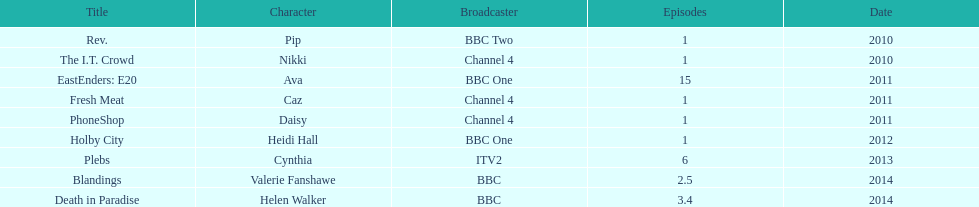Blandings and death in paradise both aired on which broadcaster? BBC. 